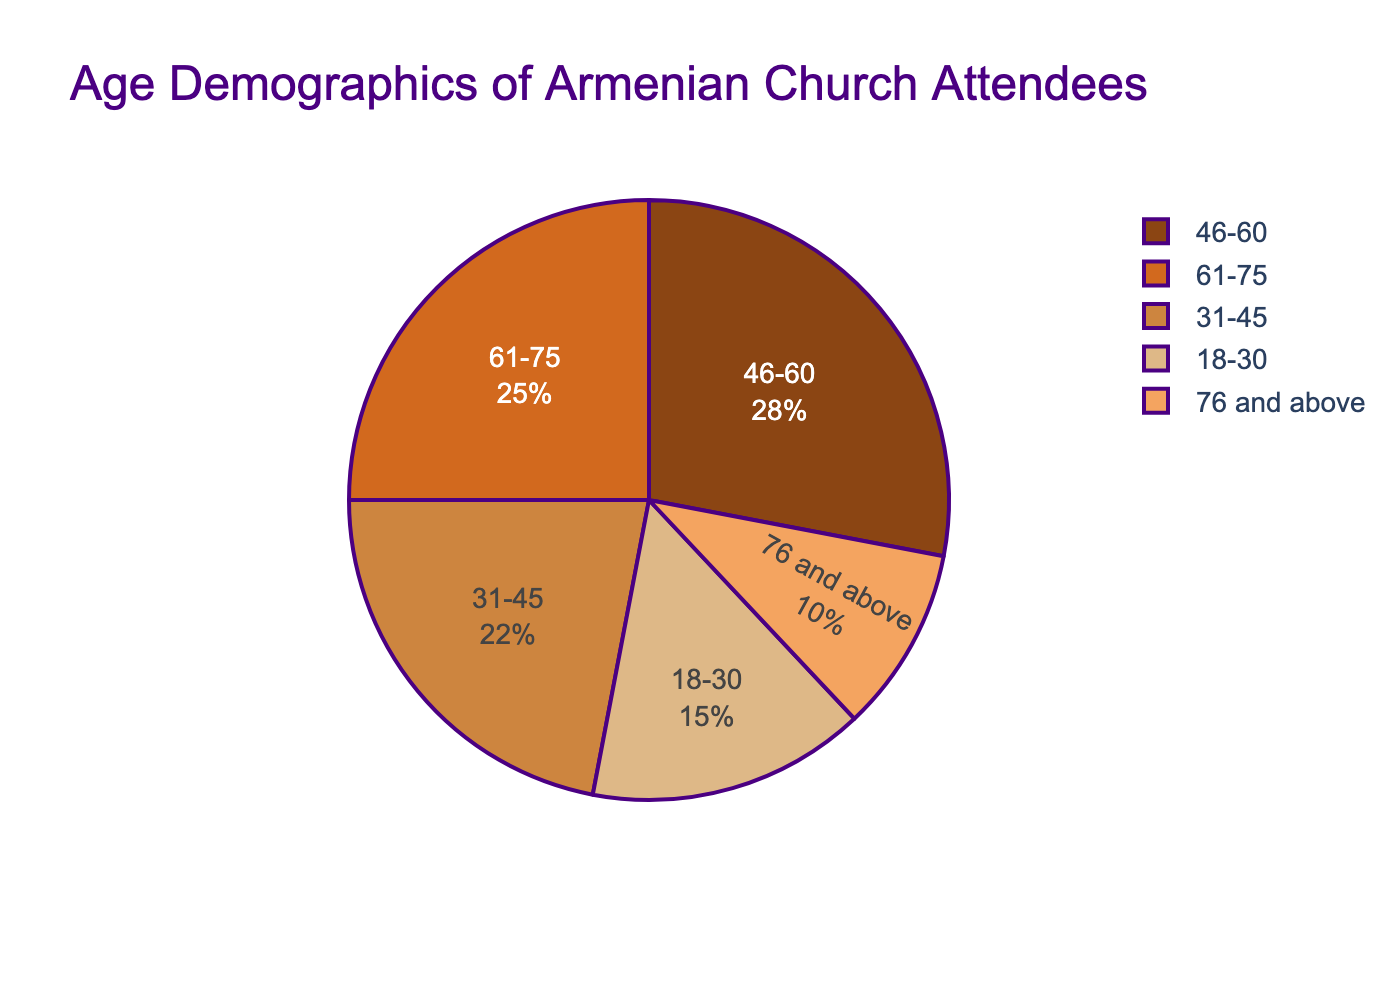What percentage of the Armenian church attendees are aged between 46-60? Locate the age group 46-60 on the pie chart and note the percentage associated with it.
Answer: 28% Which age group has the smallest representation? Identify the age group with the smallest percentage in the pie chart.
Answer: 76 and above How much larger is the 46-60 age group's percentage compared to the 18-30 age group? Find the percentage for each group: 28% for 46-60 and 15% for 18-30. Subtract the smaller percentage from the larger percentage: 28% - 15% = 13%.
Answer: 13% What is the total percentage of attendees aged 61 and above? Add the percentages for the 61-75 and 76 and above age groups: 25% + 10% = 35%.
Answer: 35% Which age group has the second-highest percentage of attendees? Identify the age group with the second-highest percentage by comparing all percentages. 31-45 has 22%; 46-60 has 28%; 61-75 has 25%; 76 and above has 10%.
Answer: 61-75 What color represents the 31-45 age group in the pie chart? Look at the pie chart segment for the 31-45 age group and identify its color.
Answer: Chestnut brown How much more significant is the proportion of the 46-60 age group compared to the 76 and above age group? Compute the difference between the 46-60 and 76 and above age groups: 28% - 10% = 18%.
Answer: 18% Is the proportion of attendees aged 31-45 greater than those aged 61-75? Compare the percentages of the two groups: 22% (31-45) vs. 25% (61-75).
Answer: No What is the combined percentage of the two most represented age groups? Identify the two largest percentages: 46-60 (28%) and 61-75 (25%). Add them together: 28% + 25% = 53%.
Answer: 53% Are there more attendees aged below 31 or above 60? Compare the combined percentages of attendees below 31 (18-30: 15%) and above 60 (61-75: 25%, 76 and above: 10%). For below 31: 15%. For above 60: 25% + 10% = 35%.
Answer: Above 60 